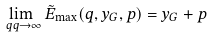Convert formula to latex. <formula><loc_0><loc_0><loc_500><loc_500>\lim _ { \ q q \to \infty } \tilde { E } _ { \max } ( q , y _ { G } , p ) = y _ { G } + p</formula> 